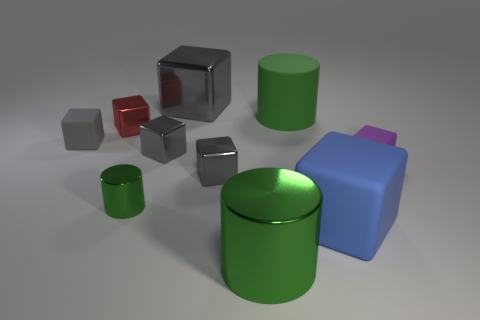What color is the large metallic thing that is the same shape as the small purple matte thing?
Provide a succinct answer. Gray. There is a green cylinder in front of the blue rubber block; is its size the same as the green shiny cylinder behind the big blue block?
Provide a short and direct response. No. Is there another big object that has the same shape as the red thing?
Your answer should be very brief. Yes. Are there an equal number of purple blocks behind the purple thing and large brown matte cylinders?
Ensure brevity in your answer.  Yes. Is the size of the purple cube the same as the cylinder that is in front of the large blue matte object?
Offer a very short reply. No. What number of red things have the same material as the purple object?
Make the answer very short. 0. Is the size of the blue rubber cube the same as the purple block?
Offer a very short reply. No. Is there any other thing that is the same color as the big metallic block?
Give a very brief answer. Yes. What is the shape of the green thing that is on the right side of the small green cylinder and in front of the gray matte block?
Provide a succinct answer. Cylinder. There is a block that is to the right of the blue block; what is its size?
Your answer should be very brief. Small. 